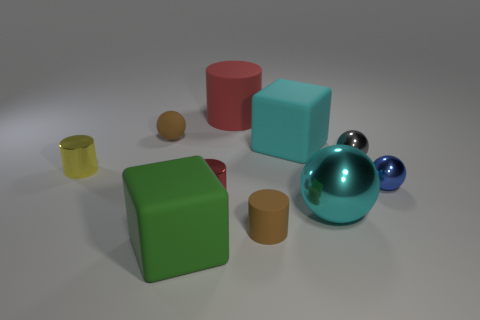There is a big cube in front of the yellow object; how many cylinders are on the left side of it?
Offer a very short reply. 1. Is there a tiny red cylinder that is in front of the block that is in front of the large matte block right of the brown rubber cylinder?
Offer a very short reply. No. What material is the tiny red thing that is the same shape as the yellow thing?
Your response must be concise. Metal. Is there any other thing that is made of the same material as the small blue object?
Provide a short and direct response. Yes. Are the large cyan cube and the block in front of the small gray metallic thing made of the same material?
Give a very brief answer. Yes. There is a large rubber thing in front of the rubber block that is behind the small yellow metallic cylinder; what is its shape?
Offer a terse response. Cube. How many big things are rubber things or cyan shiny things?
Offer a terse response. 4. What number of big rubber things have the same shape as the cyan metal object?
Keep it short and to the point. 0. There is a green rubber thing; does it have the same shape as the brown matte thing in front of the tiny gray metal thing?
Give a very brief answer. No. There is a cyan sphere; how many blue things are in front of it?
Your response must be concise. 0. 